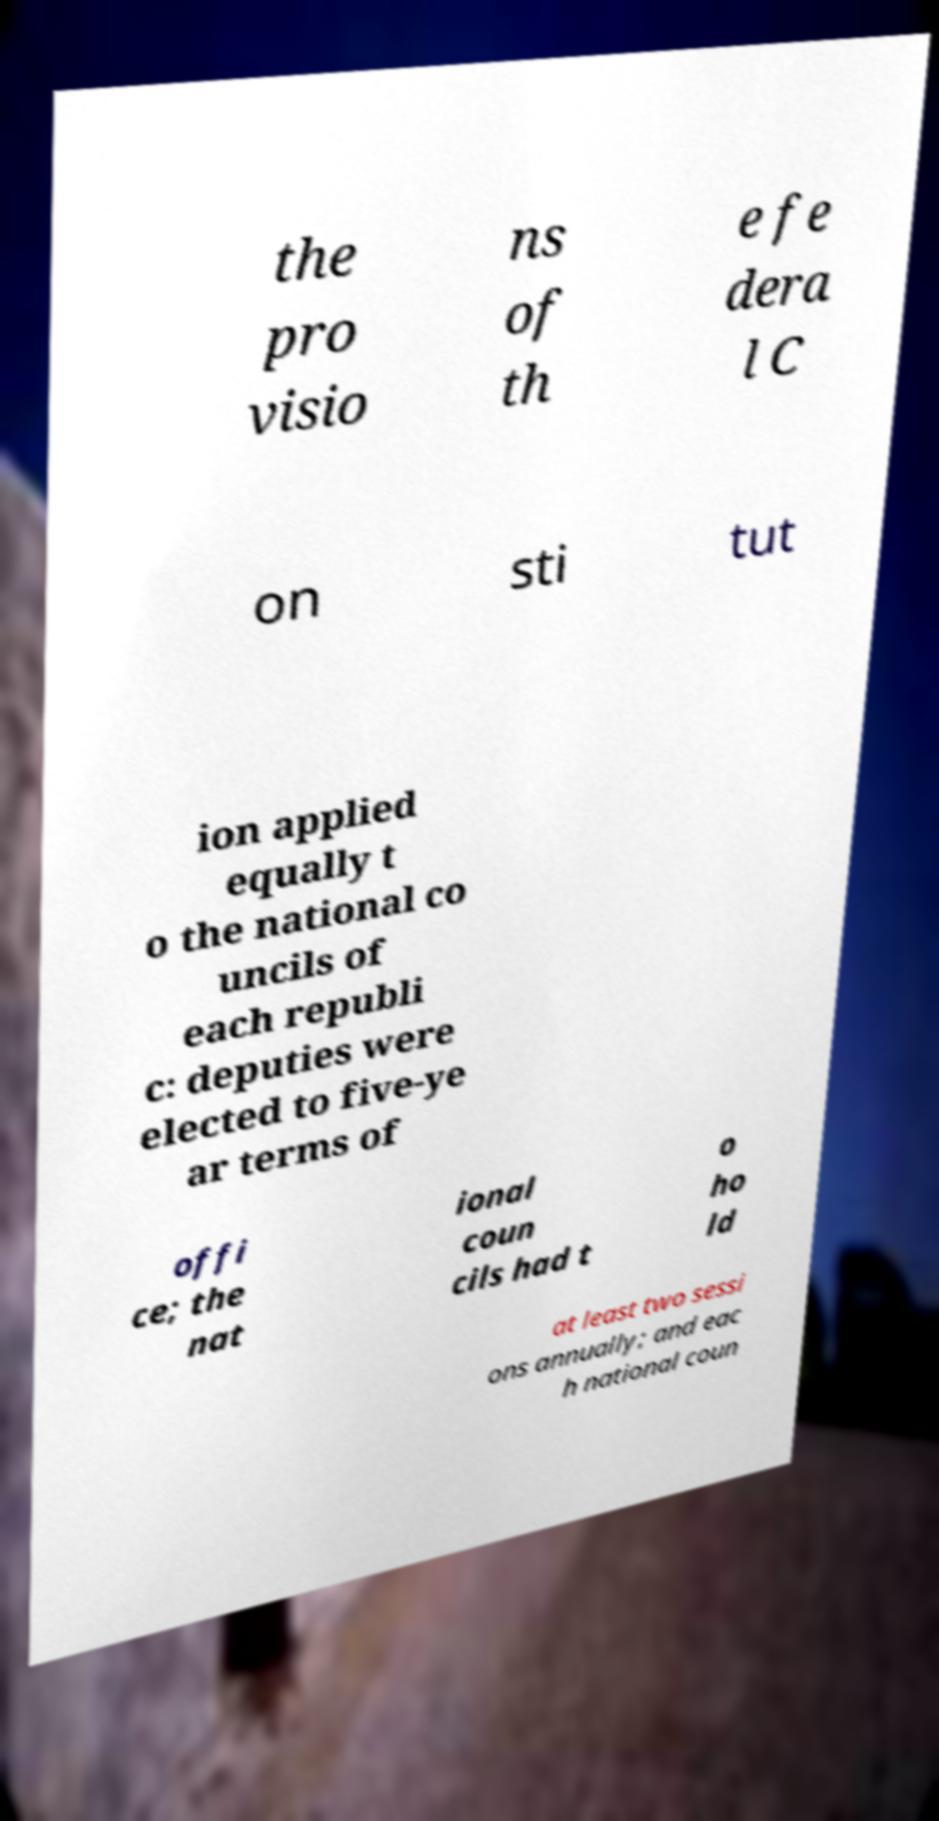I need the written content from this picture converted into text. Can you do that? the pro visio ns of th e fe dera l C on sti tut ion applied equally t o the national co uncils of each republi c: deputies were elected to five-ye ar terms of offi ce; the nat ional coun cils had t o ho ld at least two sessi ons annually; and eac h national coun 